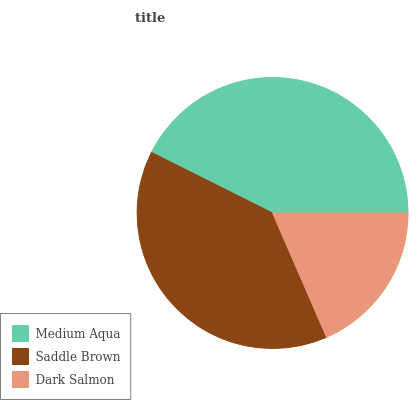Is Dark Salmon the minimum?
Answer yes or no. Yes. Is Medium Aqua the maximum?
Answer yes or no. Yes. Is Saddle Brown the minimum?
Answer yes or no. No. Is Saddle Brown the maximum?
Answer yes or no. No. Is Medium Aqua greater than Saddle Brown?
Answer yes or no. Yes. Is Saddle Brown less than Medium Aqua?
Answer yes or no. Yes. Is Saddle Brown greater than Medium Aqua?
Answer yes or no. No. Is Medium Aqua less than Saddle Brown?
Answer yes or no. No. Is Saddle Brown the high median?
Answer yes or no. Yes. Is Saddle Brown the low median?
Answer yes or no. Yes. Is Medium Aqua the high median?
Answer yes or no. No. Is Dark Salmon the low median?
Answer yes or no. No. 